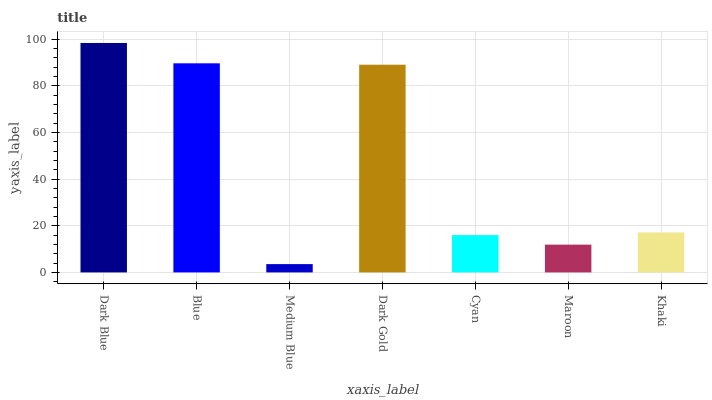Is Medium Blue the minimum?
Answer yes or no. Yes. Is Dark Blue the maximum?
Answer yes or no. Yes. Is Blue the minimum?
Answer yes or no. No. Is Blue the maximum?
Answer yes or no. No. Is Dark Blue greater than Blue?
Answer yes or no. Yes. Is Blue less than Dark Blue?
Answer yes or no. Yes. Is Blue greater than Dark Blue?
Answer yes or no. No. Is Dark Blue less than Blue?
Answer yes or no. No. Is Khaki the high median?
Answer yes or no. Yes. Is Khaki the low median?
Answer yes or no. Yes. Is Medium Blue the high median?
Answer yes or no. No. Is Maroon the low median?
Answer yes or no. No. 